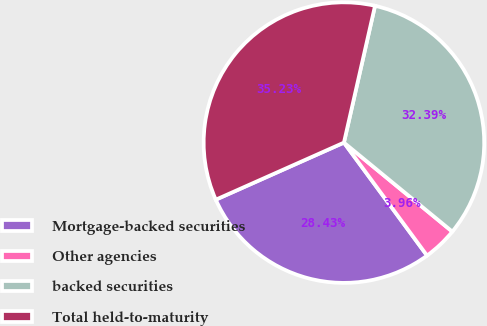<chart> <loc_0><loc_0><loc_500><loc_500><pie_chart><fcel>Mortgage-backed securities<fcel>Other agencies<fcel>backed securities<fcel>Total held-to-maturity<nl><fcel>28.43%<fcel>3.96%<fcel>32.39%<fcel>35.23%<nl></chart> 